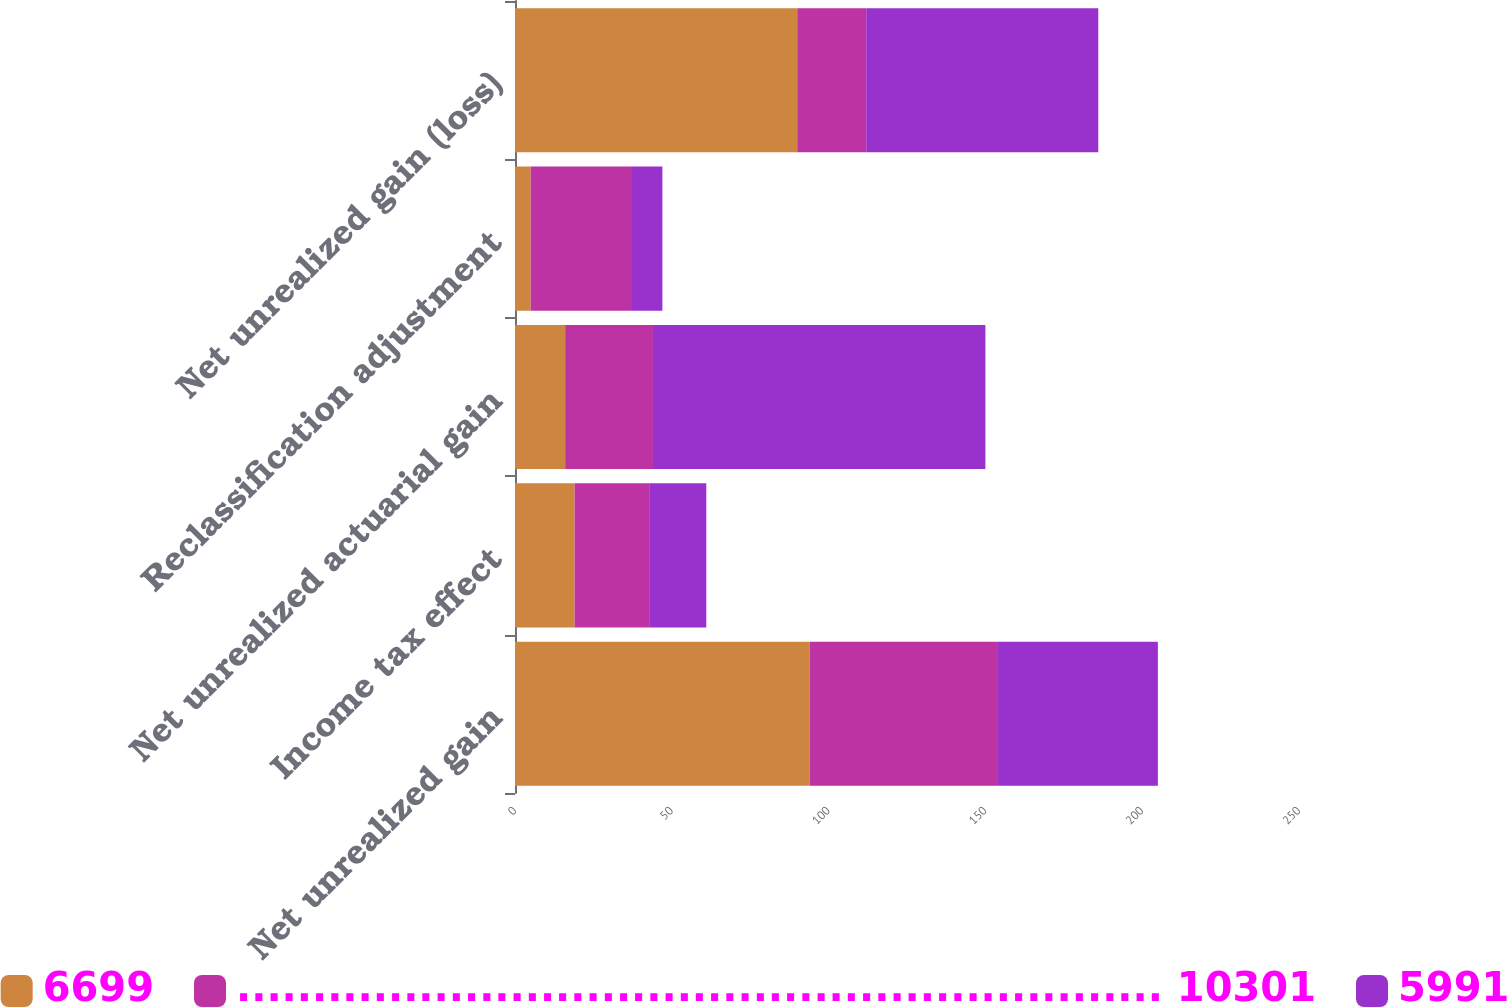Convert chart to OTSL. <chart><loc_0><loc_0><loc_500><loc_500><stacked_bar_chart><ecel><fcel>Net unrealized gain<fcel>Income tax effect<fcel>Net unrealized actuarial gain<fcel>Reclassification adjustment<fcel>Net unrealized gain (loss)<nl><fcel>6699<fcel>94<fcel>19<fcel>16<fcel>5<fcel>90<nl><fcel>............................................................. 10301<fcel>60<fcel>24<fcel>28<fcel>32<fcel>22<nl><fcel>5991<fcel>51<fcel>18<fcel>106<fcel>10<fcel>74<nl></chart> 